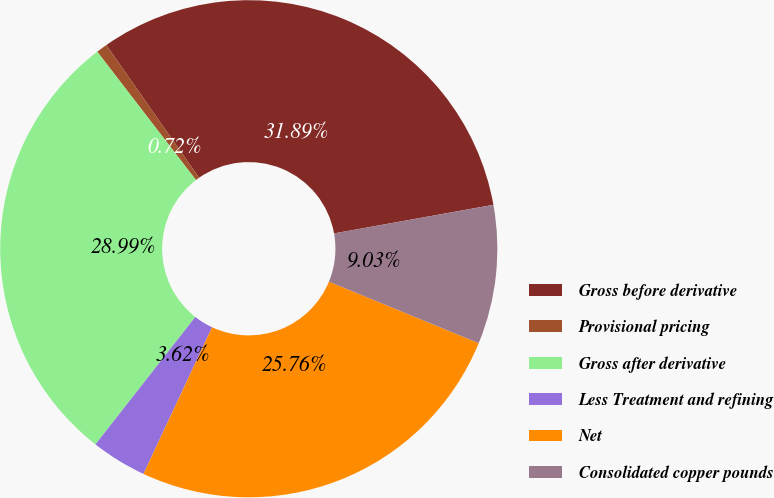<chart> <loc_0><loc_0><loc_500><loc_500><pie_chart><fcel>Gross before derivative<fcel>Provisional pricing<fcel>Gross after derivative<fcel>Less Treatment and refining<fcel>Net<fcel>Consolidated copper pounds<nl><fcel>31.89%<fcel>0.72%<fcel>28.99%<fcel>3.62%<fcel>25.76%<fcel>9.03%<nl></chart> 